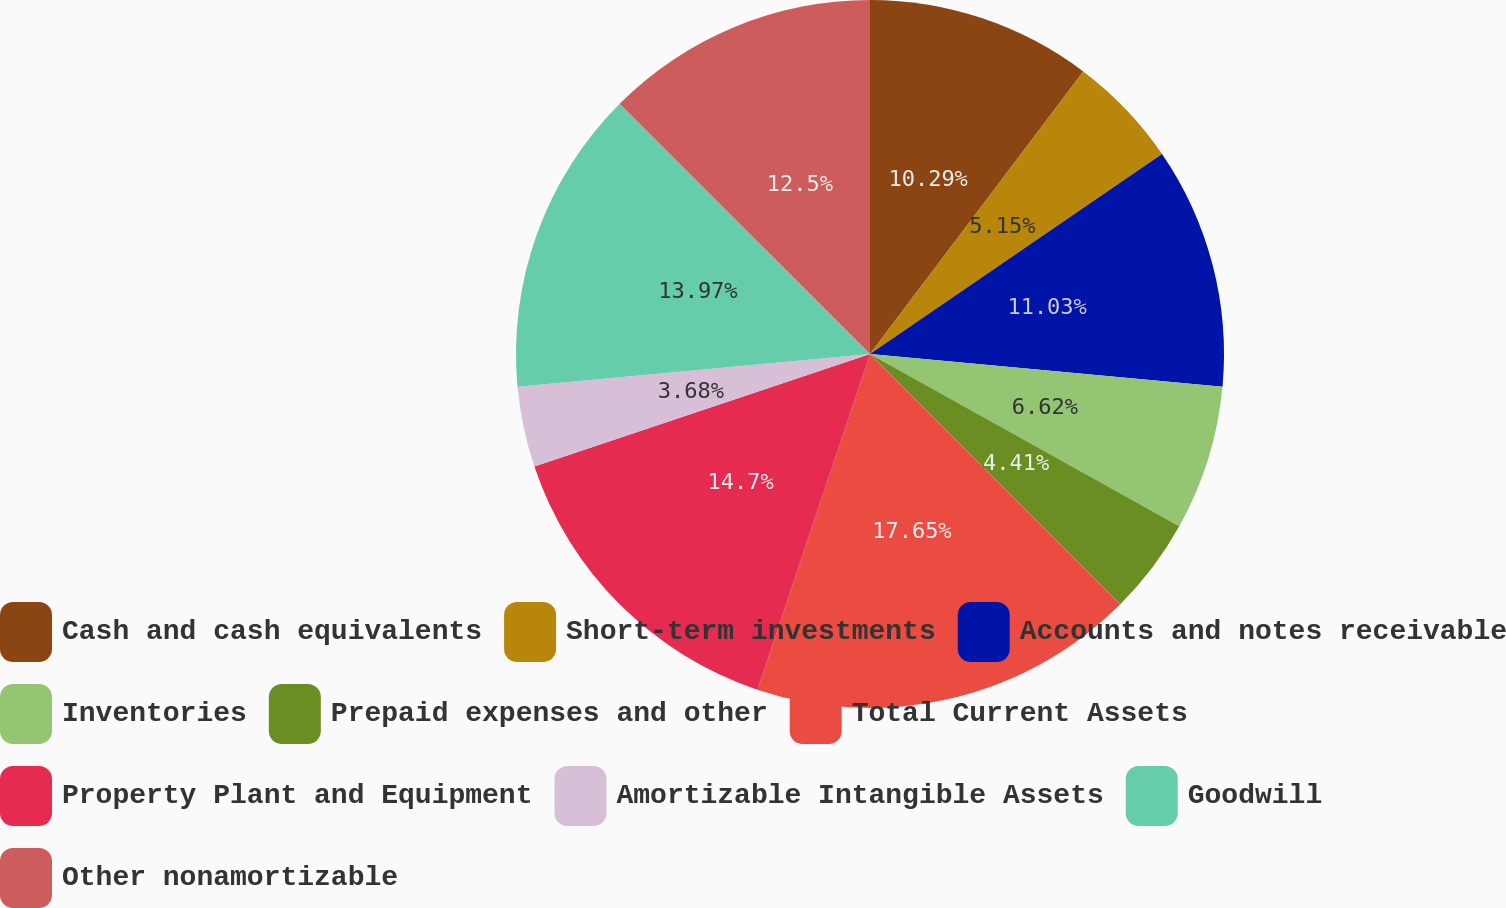Convert chart to OTSL. <chart><loc_0><loc_0><loc_500><loc_500><pie_chart><fcel>Cash and cash equivalents<fcel>Short-term investments<fcel>Accounts and notes receivable<fcel>Inventories<fcel>Prepaid expenses and other<fcel>Total Current Assets<fcel>Property Plant and Equipment<fcel>Amortizable Intangible Assets<fcel>Goodwill<fcel>Other nonamortizable<nl><fcel>10.29%<fcel>5.15%<fcel>11.03%<fcel>6.62%<fcel>4.41%<fcel>17.65%<fcel>14.7%<fcel>3.68%<fcel>13.97%<fcel>12.5%<nl></chart> 